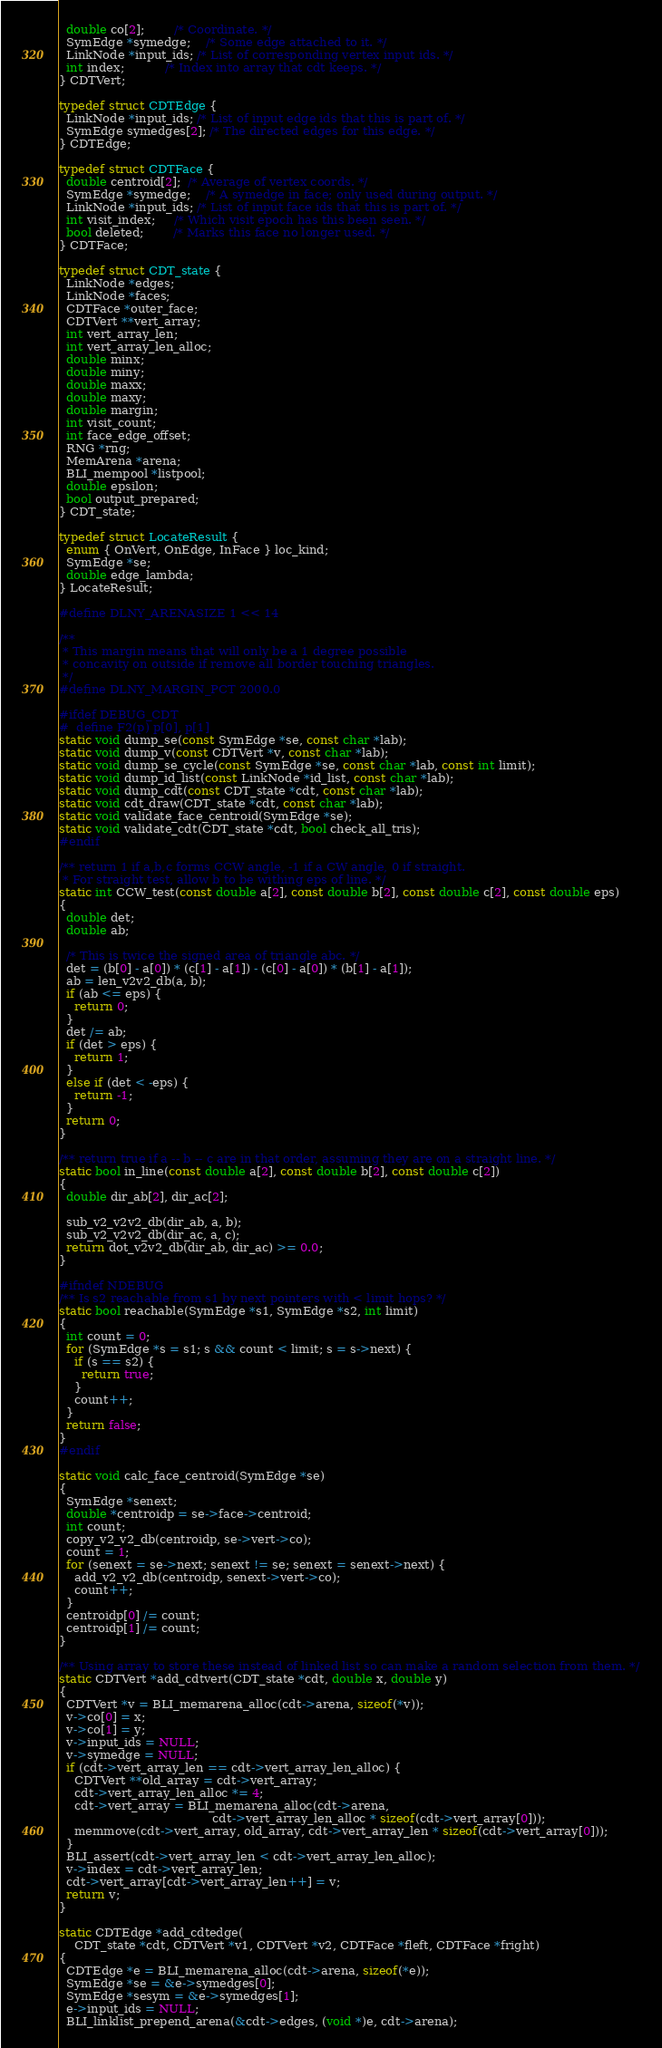<code> <loc_0><loc_0><loc_500><loc_500><_C_>  double co[2];        /* Coordinate. */
  SymEdge *symedge;    /* Some edge attached to it. */
  LinkNode *input_ids; /* List of corresponding vertex input ids. */
  int index;           /* Index into array that cdt keeps. */
} CDTVert;

typedef struct CDTEdge {
  LinkNode *input_ids; /* List of input edge ids that this is part of. */
  SymEdge symedges[2]; /* The directed edges for this edge. */
} CDTEdge;

typedef struct CDTFace {
  double centroid[2];  /* Average of vertex coords. */
  SymEdge *symedge;    /* A symedge in face; only used during output. */
  LinkNode *input_ids; /* List of input face ids that this is part of. */
  int visit_index;     /* Which visit epoch has this been seen. */
  bool deleted;        /* Marks this face no longer used. */
} CDTFace;

typedef struct CDT_state {
  LinkNode *edges;
  LinkNode *faces;
  CDTFace *outer_face;
  CDTVert **vert_array;
  int vert_array_len;
  int vert_array_len_alloc;
  double minx;
  double miny;
  double maxx;
  double maxy;
  double margin;
  int visit_count;
  int face_edge_offset;
  RNG *rng;
  MemArena *arena;
  BLI_mempool *listpool;
  double epsilon;
  bool output_prepared;
} CDT_state;

typedef struct LocateResult {
  enum { OnVert, OnEdge, InFace } loc_kind;
  SymEdge *se;
  double edge_lambda;
} LocateResult;

#define DLNY_ARENASIZE 1 << 14

/**
 * This margin means that will only be a 1 degree possible
 * concavity on outside if remove all border touching triangles.
 */
#define DLNY_MARGIN_PCT 2000.0

#ifdef DEBUG_CDT
#  define F2(p) p[0], p[1]
static void dump_se(const SymEdge *se, const char *lab);
static void dump_v(const CDTVert *v, const char *lab);
static void dump_se_cycle(const SymEdge *se, const char *lab, const int limit);
static void dump_id_list(const LinkNode *id_list, const char *lab);
static void dump_cdt(const CDT_state *cdt, const char *lab);
static void cdt_draw(CDT_state *cdt, const char *lab);
static void validate_face_centroid(SymEdge *se);
static void validate_cdt(CDT_state *cdt, bool check_all_tris);
#endif

/** return 1 if a,b,c forms CCW angle, -1 if a CW angle, 0 if straight.
 * For straight test, allow b to be withing eps of line. */
static int CCW_test(const double a[2], const double b[2], const double c[2], const double eps)
{
  double det;
  double ab;

  /* This is twice the signed area of triangle abc. */
  det = (b[0] - a[0]) * (c[1] - a[1]) - (c[0] - a[0]) * (b[1] - a[1]);
  ab = len_v2v2_db(a, b);
  if (ab <= eps) {
    return 0;
  }
  det /= ab;
  if (det > eps) {
    return 1;
  }
  else if (det < -eps) {
    return -1;
  }
  return 0;
}

/** return true if a -- b -- c are in that order, assuming they are on a straight line. */
static bool in_line(const double a[2], const double b[2], const double c[2])
{
  double dir_ab[2], dir_ac[2];

  sub_v2_v2v2_db(dir_ab, a, b);
  sub_v2_v2v2_db(dir_ac, a, c);
  return dot_v2v2_db(dir_ab, dir_ac) >= 0.0;
}

#ifndef NDEBUG
/** Is s2 reachable from s1 by next pointers with < limit hops? */
static bool reachable(SymEdge *s1, SymEdge *s2, int limit)
{
  int count = 0;
  for (SymEdge *s = s1; s && count < limit; s = s->next) {
    if (s == s2) {
      return true;
    }
    count++;
  }
  return false;
}
#endif

static void calc_face_centroid(SymEdge *se)
{
  SymEdge *senext;
  double *centroidp = se->face->centroid;
  int count;
  copy_v2_v2_db(centroidp, se->vert->co);
  count = 1;
  for (senext = se->next; senext != se; senext = senext->next) {
    add_v2_v2_db(centroidp, senext->vert->co);
    count++;
  }
  centroidp[0] /= count;
  centroidp[1] /= count;
}

/** Using array to store these instead of linked list so can make a random selection from them. */
static CDTVert *add_cdtvert(CDT_state *cdt, double x, double y)
{
  CDTVert *v = BLI_memarena_alloc(cdt->arena, sizeof(*v));
  v->co[0] = x;
  v->co[1] = y;
  v->input_ids = NULL;
  v->symedge = NULL;
  if (cdt->vert_array_len == cdt->vert_array_len_alloc) {
    CDTVert **old_array = cdt->vert_array;
    cdt->vert_array_len_alloc *= 4;
    cdt->vert_array = BLI_memarena_alloc(cdt->arena,
                                         cdt->vert_array_len_alloc * sizeof(cdt->vert_array[0]));
    memmove(cdt->vert_array, old_array, cdt->vert_array_len * sizeof(cdt->vert_array[0]));
  }
  BLI_assert(cdt->vert_array_len < cdt->vert_array_len_alloc);
  v->index = cdt->vert_array_len;
  cdt->vert_array[cdt->vert_array_len++] = v;
  return v;
}

static CDTEdge *add_cdtedge(
    CDT_state *cdt, CDTVert *v1, CDTVert *v2, CDTFace *fleft, CDTFace *fright)
{
  CDTEdge *e = BLI_memarena_alloc(cdt->arena, sizeof(*e));
  SymEdge *se = &e->symedges[0];
  SymEdge *sesym = &e->symedges[1];
  e->input_ids = NULL;
  BLI_linklist_prepend_arena(&cdt->edges, (void *)e, cdt->arena);</code> 